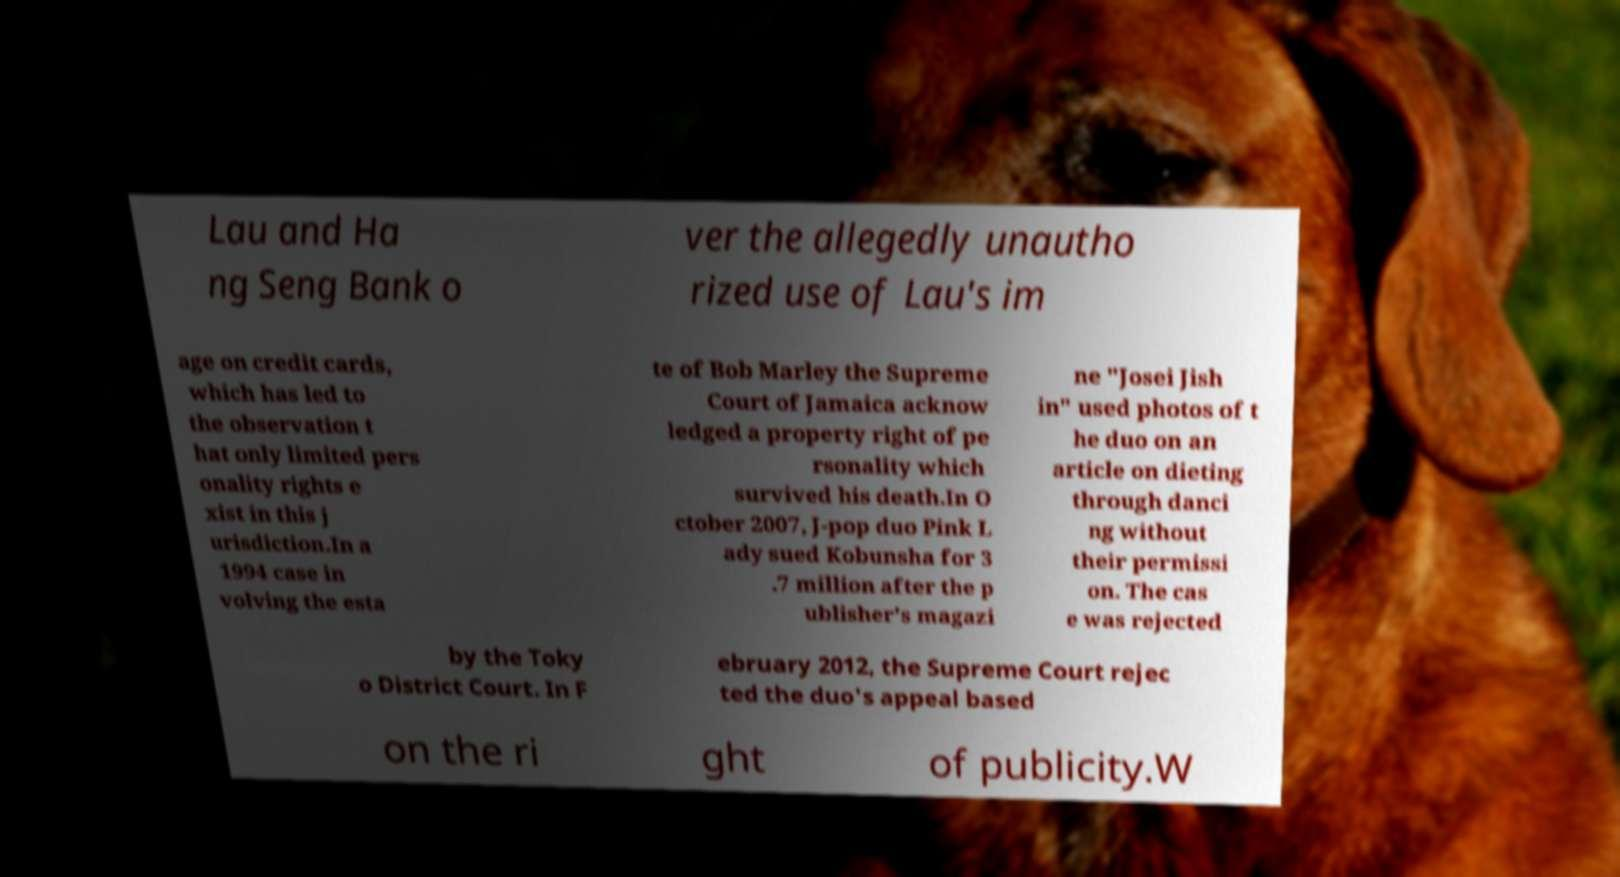Could you extract and type out the text from this image? Lau and Ha ng Seng Bank o ver the allegedly unautho rized use of Lau's im age on credit cards, which has led to the observation t hat only limited pers onality rights e xist in this j urisdiction.In a 1994 case in volving the esta te of Bob Marley the Supreme Court of Jamaica acknow ledged a property right of pe rsonality which survived his death.In O ctober 2007, J-pop duo Pink L ady sued Kobunsha for 3 .7 million after the p ublisher's magazi ne "Josei Jish in" used photos of t he duo on an article on dieting through danci ng without their permissi on. The cas e was rejected by the Toky o District Court. In F ebruary 2012, the Supreme Court rejec ted the duo's appeal based on the ri ght of publicity.W 